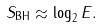<formula> <loc_0><loc_0><loc_500><loc_500>S _ { \text {BH} } \approx \log _ { 2 } E .</formula> 